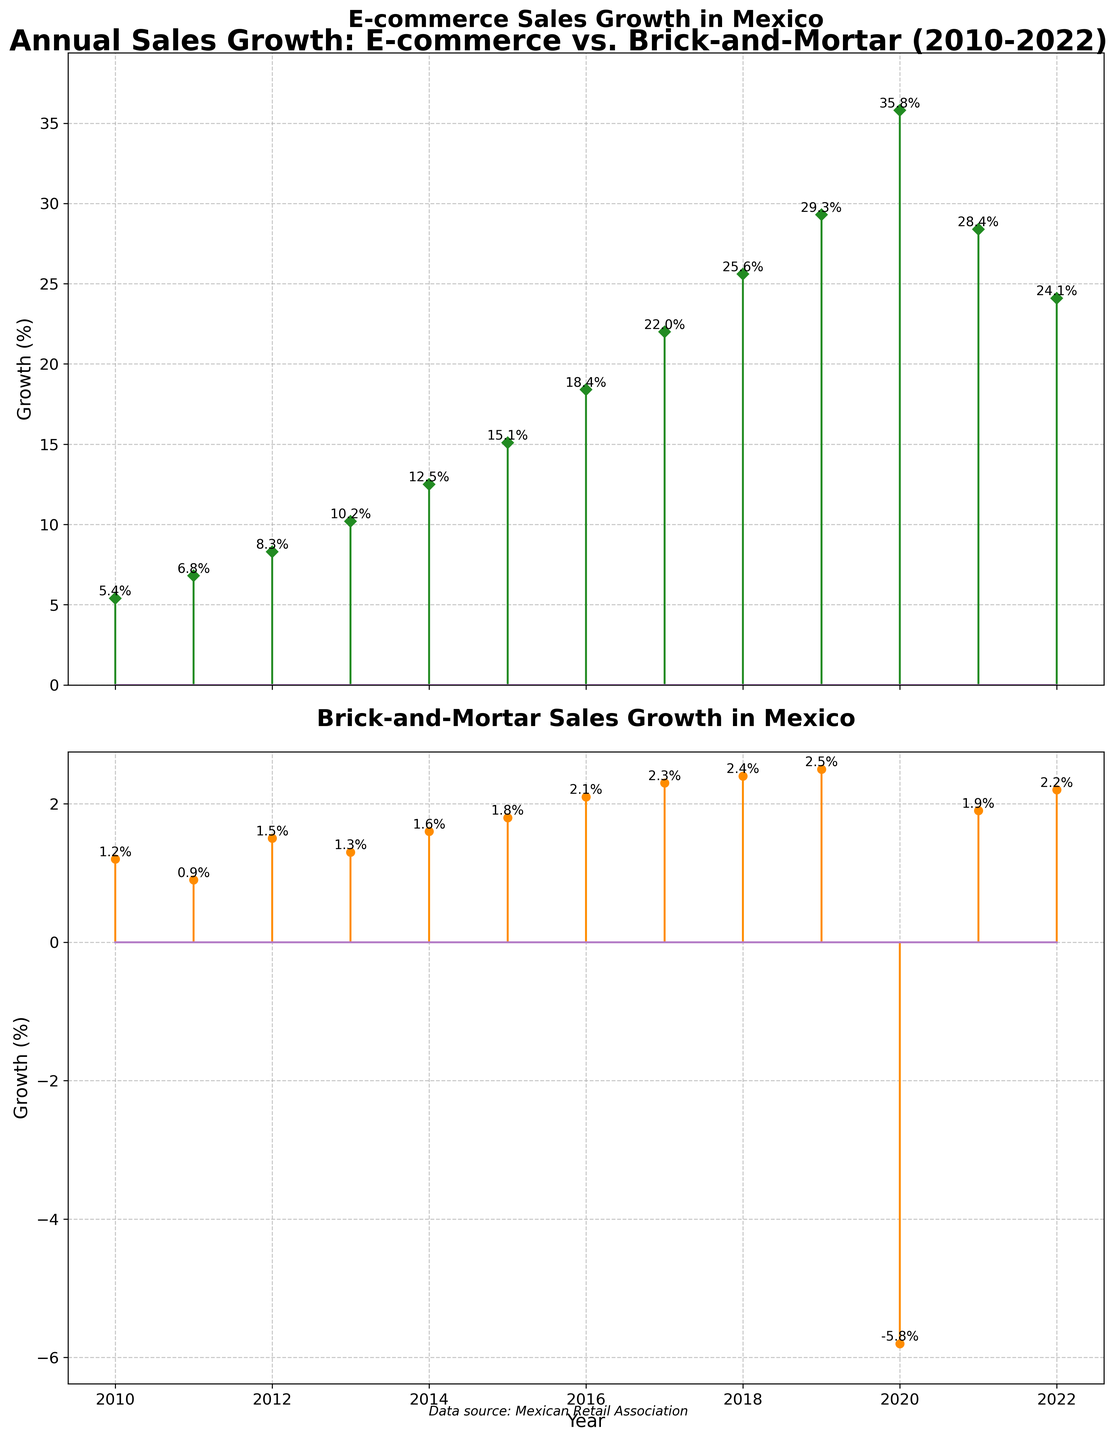What years are covered in the data for the annual sales growth? The x-axis of both subplots covers the span of years, ranging from 2010 to 2022.
Answer: 2010 to 2022 What is the highest growth percentage for E-commerce, and in which year does it occur? The tallest stem in the top subplot represents the highest E-commerce growth, marked at 35.8% for the year 2020.
Answer: 35.8% in 2020 How did Brick-and-Mortar sales perform in 2020 compared to the other years? The second subplot shows a drastic dip in sales for Brick-and-Mortar in 2020, with a growth rate of -5.8%, which is significantly different from the positive growth in other years.
Answer: -5.8% in 2020 Which year saw the smallest growth in Brick-and-Mortar sales, excluding the year with negative growth? Excluding 2020, the year with the smallest growth in Brick-and-Mortar sales is 2011, with a growth rate of 0.9%.
Answer: 2011 with 0.9% Compare the general trends of sales growth for E-commerce and Brick-and-Mortar from 2010 to 2022. From 2010 to 2022, E-commerce shows a consistent upward trend in growth (with a peak in 2020), while Brick-and-Mortar maintains a much slower and relatively stable growth with a significant dip in 2020.
Answer: E-commerce upward, Brick-and-Mortar stable with a 2020 dip What was the growth rate difference between E-commerce and Brick-and-Mortar in the year 2016? In 2016, the growth rate for E-commerce was 18.4% and for Brick-and-Mortar it was 2.1%. The difference is calculated as 18.4% - 2.1% = 16.3%.
Answer: 16.3% Calculate the average annual growth percentage for E-commerce over the entire period. Sum the E-commerce growth percentages and divide by the number of years: (5.4 + 6.8 + 8.3 + 10.2 + 12.5 + 15.1 + 18.4 + 22.0 + 25.6 + 29.3 + 35.8 + 28.4 + 24.1) / 13 = 18.4%.
Answer: 18.4% In which year did E-commerce sales growth exceed 20% for the first time? The top subplot shows the E-commerce sales growth exceeding 20% for the first time in the year 2017, marked at 22.0%.
Answer: 2017 Compare the growth rates of Brick-and-Mortar in 2021 and 2022. The growth rates for Brick-and-Mortar were 1.9% in 2021 and 2.2% in 2022, indicating a slight increase from 2021 to 2022.
Answer: 2.2% in 2022, 1.9% in 2021 Which year shows the greatest gap between the growth rates of E-commerce and Brick-and-Mortar, and what is the gap value? The year 2020 shows the greatest gap, where E-commerce had a growth rate of 35.8% and Brick-and-Mortar had -5.8%. The gap is calculated as 35.8% - (-5.8%) = 41.6%.
Answer: 2020, 41.6% 